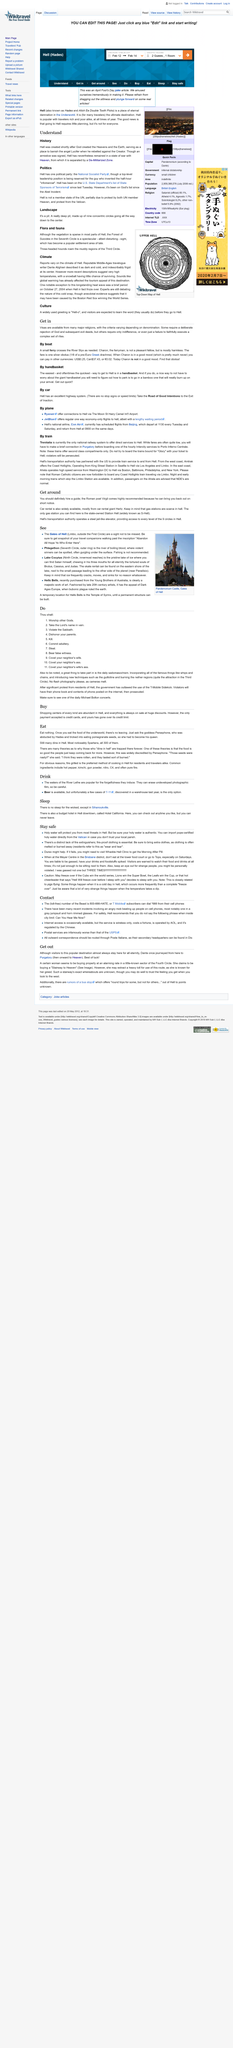Draw attention to some important aspects in this diagram. Dante Alighieri, a travelogue writer, described the climate of Hell in his work. Yes, condoms are recommended as a means to ensure safety in this article. The small ferry is the vessel that crosses the river Styx as needed. The woman claims to be purchasing a "Stairway to Heaven. It is possible to obtain the morning after pill at the Whadda Hell Clinic in Hell. 